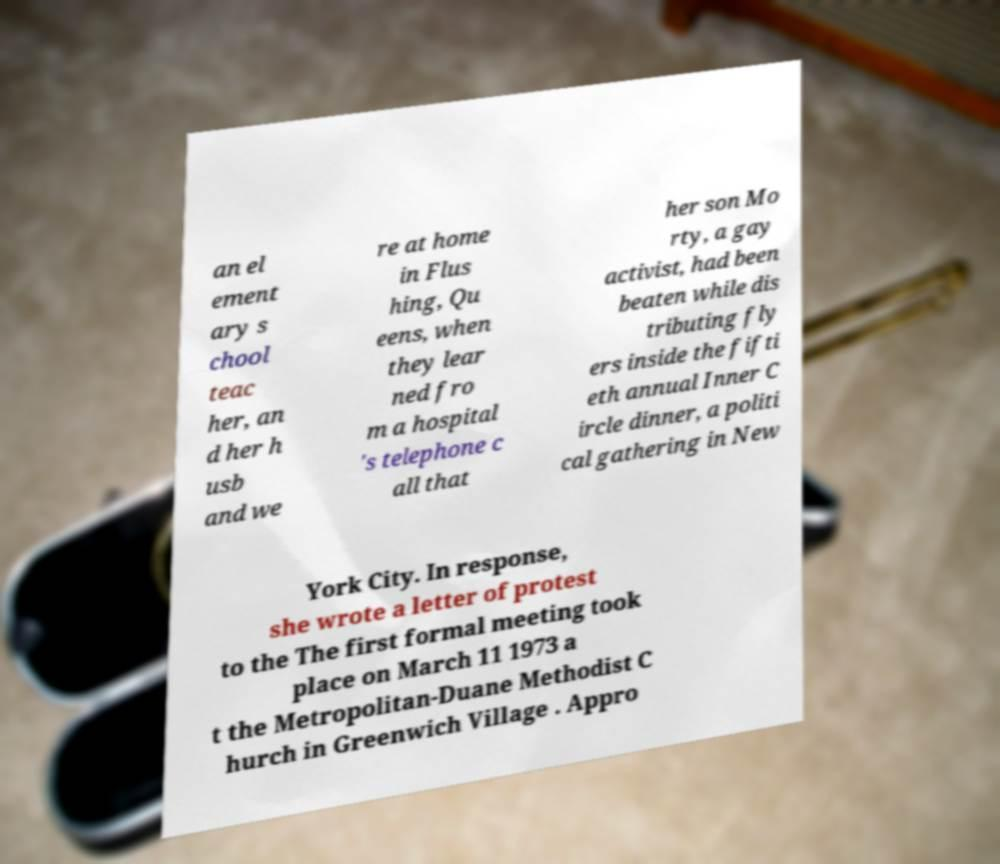What messages or text are displayed in this image? I need them in a readable, typed format. an el ement ary s chool teac her, an d her h usb and we re at home in Flus hing, Qu eens, when they lear ned fro m a hospital 's telephone c all that her son Mo rty, a gay activist, had been beaten while dis tributing fly ers inside the fifti eth annual Inner C ircle dinner, a politi cal gathering in New York City. In response, she wrote a letter of protest to the The first formal meeting took place on March 11 1973 a t the Metropolitan-Duane Methodist C hurch in Greenwich Village . Appro 